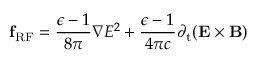Convert formula to latex. <formula><loc_0><loc_0><loc_500><loc_500>{ f _ { R F } } = \frac { \epsilon - 1 } { 8 \pi } \boldsymbol \nabla E ^ { 2 } + \frac { \epsilon - 1 } { 4 \pi c } { \partial _ { t } } ( { E } \times { B } )</formula> 